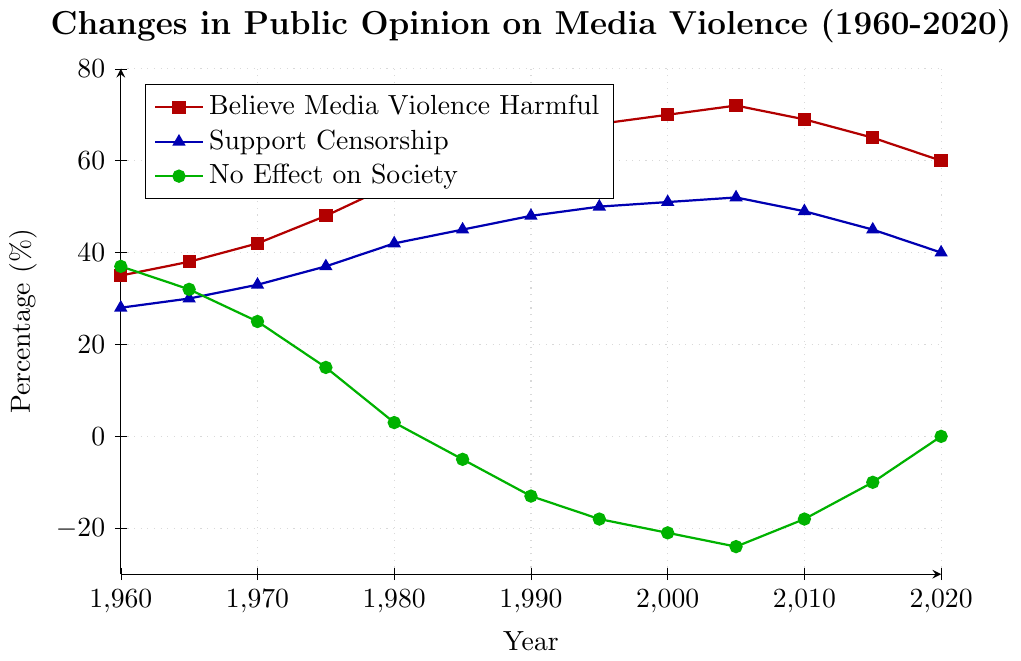What trend is observed in the percentage of people who believe media violence is harmful between 1960 and 1985? From 1960 to 1985, the figure shows a consistent increase in this percentage from 35% to 60%.
Answer: It increased What is the difference in the percentage of people who believe media violence is harmful between 1970 and 2020? In 1970, the percentage was 42%. In 2020, it was 60%. The difference is 60% - 42% = 18%.
Answer: 18% How has the public opinion about media violence having no effect on society changed from 1980 to 2020? In 1980, the percentage was 3%. By 2020, it changed to 0%.
Answer: It decreased from 3% to 0% Which year shows the highest percentage of people supporting censorship and what is the percentage? We observe from the figure that the highest percentage is in 2005, at 52%.
Answer: 2005, 52% Has the percentage of people who support censorship ever decreased over the decades shown? Yes, there is a visible decrease between 2005 and 2020 from 52% to 40%.
Answer: Yes What is the relation between the percentages of people who believe media violence is harmful and those who support censorship in 2020? In 2020, the percentage of people who believe media violence is harmful is 60%, while those who support censorship make up 40%. The belief that media violence is harmful is higher.
Answer: Belief is higher than support What is the overall trend for the percentage of people who think media violence has no effect on society? The trend has mostly been downward, starting at 37% in 1960 and ending at 0% in 2020.
Answer: Decreasing At which point in time did the percentage of people who believe media violence is harmful peak, and what was the percentage? The peak occurred in 2005, at 72%.
Answer: 2005, 72% Compare the changes in the percentage of people who believe media violence is harmful and support censorship from 1960 to 2020. The belief in harmful effects increased from 35% to 60%, while support for censorship increased from 28% to 40%. Both increased over time.
Answer: Both increased By how much did the percentage of people believing media violence is harmful change between 1975 and 2010? In 1975, the percentage was 48%, while in 2010 it was 69%. The change is 69% - 48% = 21%.
Answer: 21% 